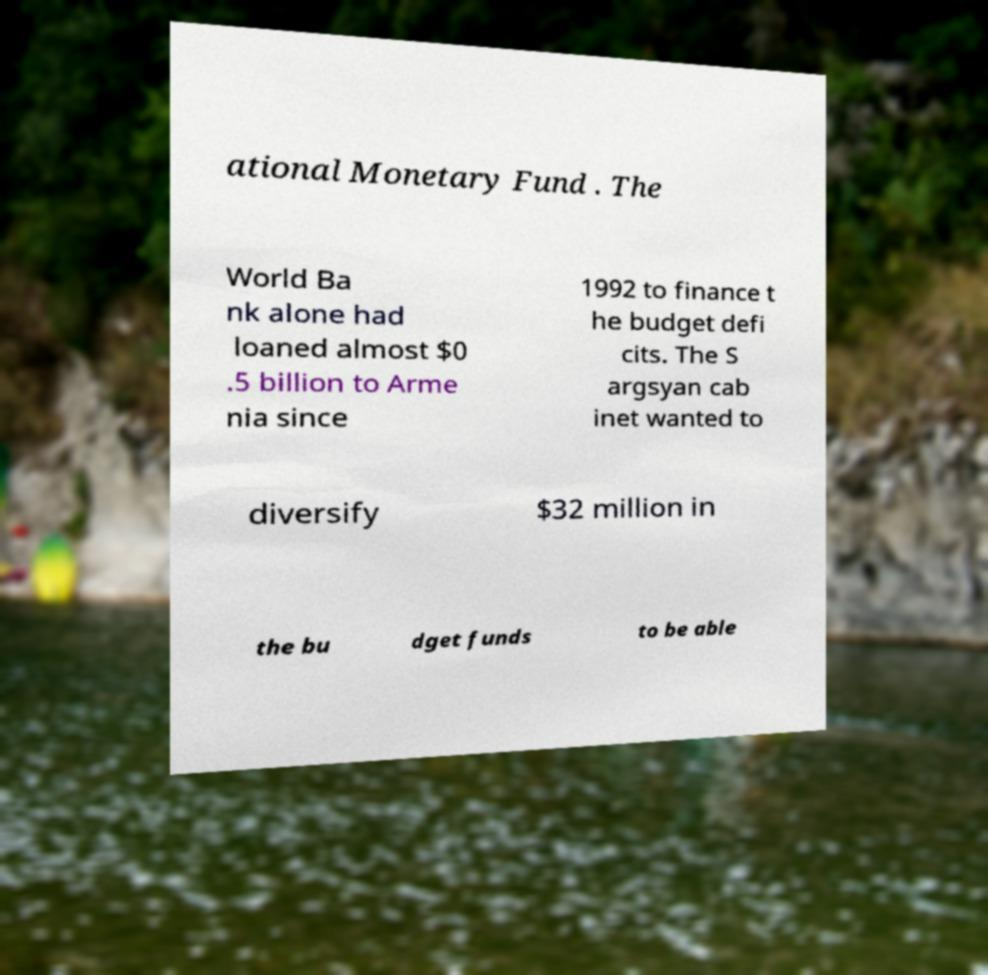Can you accurately transcribe the text from the provided image for me? ational Monetary Fund . The World Ba nk alone had loaned almost $0 .5 billion to Arme nia since 1992 to finance t he budget defi cits. The S argsyan cab inet wanted to diversify $32 million in the bu dget funds to be able 